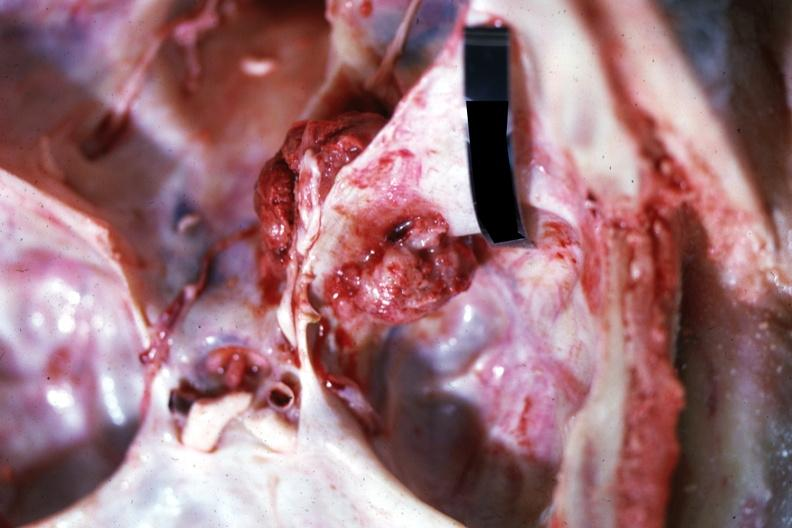does outside adrenal capsule section show close-up view of meaty appearing metastatic lesion in temporal and posterior fossa?
Answer the question using a single word or phrase. No 